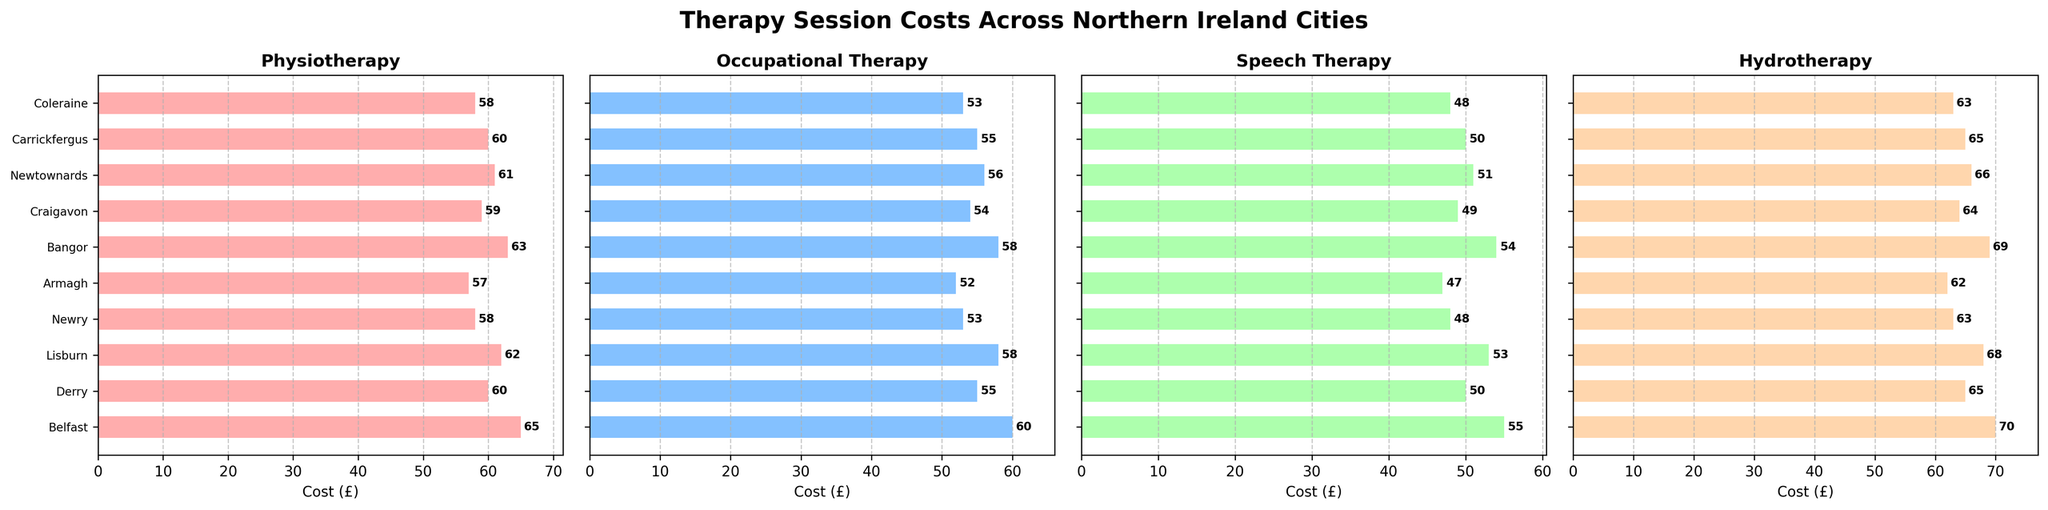What is the average cost of Physiotherapy sessions across all cities? To find the average cost of Physiotherapy sessions, we sum all the costs and divide by the number of cities. The costs are 65, 60, 62, 58, 57, 63, 59, 61, 60, 58. Sum = 603, Number of cities = 10, so the average is 603 / 10 = 60.3
Answer: 60.3 Which city offers the least expensive Speech Therapy sessions? By looking at the Speech Therapy costs, we see the values 55, 50, 53, 48, 47, 54, 49, 51, 50, 48. The lowest cost is 47, which is in Armagh.
Answer: Armagh Is the cost of Hydrotherapy in Belfast higher than in Derry? In the Hydrotherapy subplot, the cost in Belfast is 70 and in Derry is 65. Since 70 is greater than 65, the cost in Belfast is higher.
Answer: Yes What is the difference between the most expensive and least expensive Occupational Therapy sessions? The Occupational Therapy costs are 60, 55, 58, 53, 52, 58, 54, 56, 55, 53. The most expensive is 60 and the least expensive is 52. The difference is 60 - 52 = 8
Answer: 8 Which city has the highest average therapy session cost (considering all four types of therapy)? We need to compute the average cost for each city by summing the costs of all four therapies and dividing by 4. Example for Belfast: (65 + 60 + 55 + 70) / 4 = 62.5. Performing this for all cities, we find Belfast highest with 62.5
Answer: Belfast Are Speech Therapy sessions in Lisburn more expensive than Occupational Therapy sessions in the same city? In the subplot for Lisburn, the cost for Speech Therapy is 53, while Occupational Therapy is 58. Since 53 is less than 58, Speech Therapy is cheaper.
Answer: No What is the average cost of Hydrotherapy sessions across all cities? To find the average cost of Hydrotherapy sessions, sum all the costs and divide by the number of cities. The costs are 70, 65, 68, 63, 62, 69, 64, 66, 65, 63. Sum = 655, Number of cities = 10, so the average is 655 / 10 = 65.5
Answer: 65.5 Which cities have the same cost for Occupational Therapy sessions? The Occupational Therapy subplot shows costs of 60, 55, 58, 53, 52, 58, 54, 56, 55, 53. Derry and Carrickfergus have 55, as do Coleraine and Newry with 53.
Answer: Derry, Carrickfergus; Coleraine, Newry Which therapy type has the most variation in cost across all cities? Compare the range (difference between the highest and lowest costs) for each therapy type. Physiotherapy: 65-57 = 8, Occupational Therapy: 60-52 = 8, Speech Therapy: 55-47 = 8, Hydrotherapy: 70-62 = 8. All have similar variations of 8.
Answer: All similar 